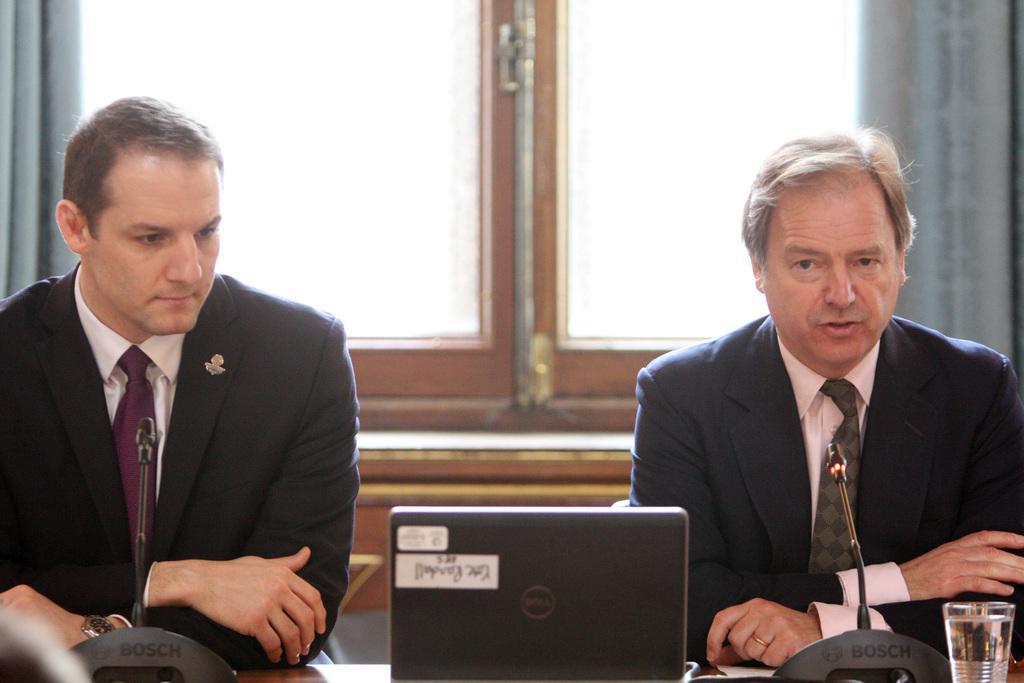Could you give a brief overview of what you see in this image? In this image we can see men sitting on the chairs and a table is placed in front of them. On the table there are mics, laptop and a glass tumbler. In the background we can see curtains and window. 